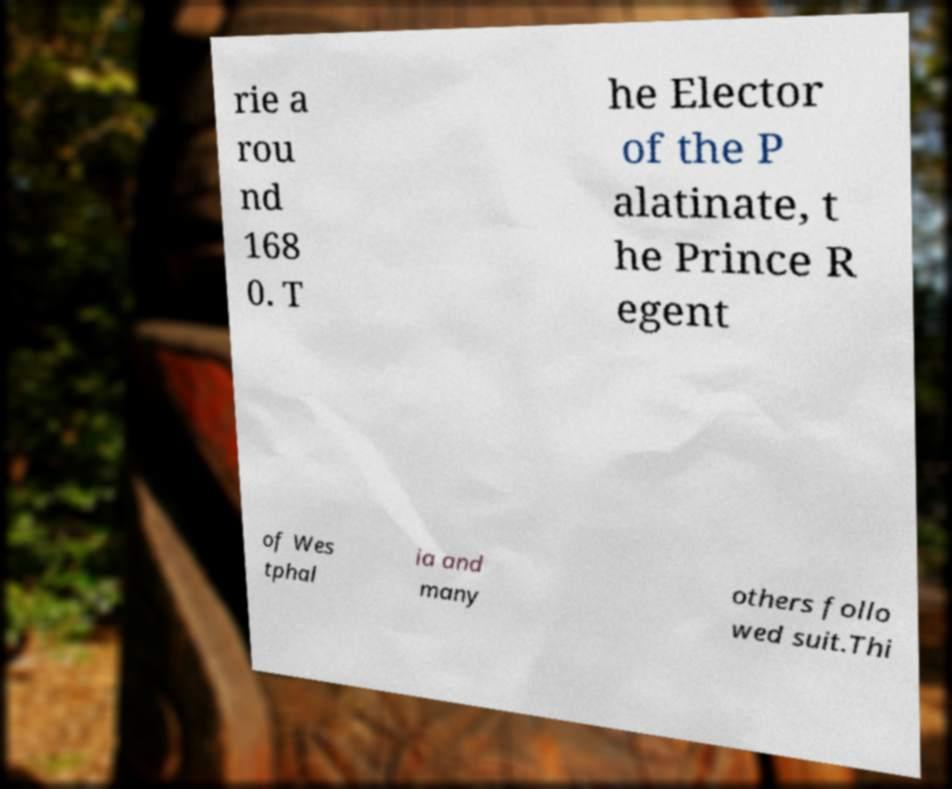Could you assist in decoding the text presented in this image and type it out clearly? rie a rou nd 168 0. T he Elector of the P alatinate, t he Prince R egent of Wes tphal ia and many others follo wed suit.Thi 